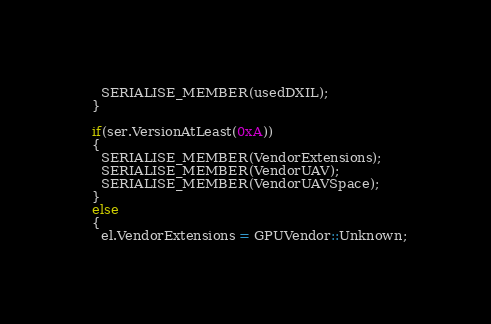Convert code to text. <code><loc_0><loc_0><loc_500><loc_500><_C++_>    SERIALISE_MEMBER(usedDXIL);
  }

  if(ser.VersionAtLeast(0xA))
  {
    SERIALISE_MEMBER(VendorExtensions);
    SERIALISE_MEMBER(VendorUAV);
    SERIALISE_MEMBER(VendorUAVSpace);
  }
  else
  {
    el.VendorExtensions = GPUVendor::Unknown;</code> 